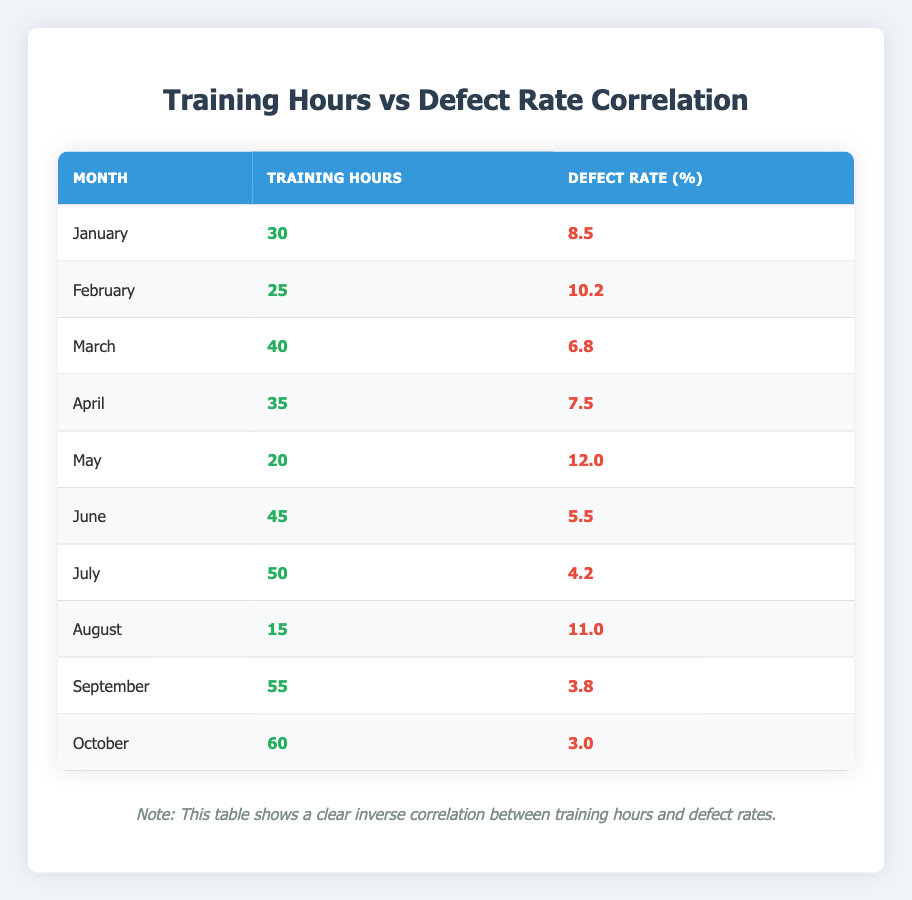What is the defect rate in June? In the table, the defect rate for June corresponds to the row where the month is June. The defect rate listed there is 5.5%.
Answer: 5.5 Which month had the highest training hours? By examining the training hours for each month in the table, September has the highest training hours at 55.
Answer: September What is the average defect rate for the months with training hours above 40? For the months that have training hours greater than 40 (March, June, July, September, and October), their defect rates are 6.8, 5.5, 4.2, 3.8, and 3.0 respectively. The sum is 6.8 + 5.5 + 4.2 + 3.8 + 3.0 = 23.3. There are 5 months, so the average is 23.3 / 5 = 4.66.
Answer: 4.66 Is it true that the defect rate decreases as training hours increase? A general trend can be inferred from the data: as training hours increase, the defect rate generally decreases. Analyzing the rows confirms that lower defect rates tend to align with higher training hours.
Answer: Yes What was the defect rate in the month with the lowest training hours? In the table, the month with the lowest training hours is August, which has 15 training hours. The defect rate for this month is listed as 11.0%.
Answer: 11.0 What is the total training hours contributed by the months with defect rates below 5%? The months with defect rates below 5% are July (50 hours), September (55 hours), and October (60 hours). Summing their training hours gives 50 + 55 + 60 = 165.
Answer: 165 How many months had a defect rate above 10%? Looking at the defect rates in the table, the months February (10.2%), May (12.0%), and August (11.0%) had defect rates higher than 10%. That totals to three months.
Answer: 3 What is the difference in defect rate between the month with the maximum training hours and the month with the minimum training hours? September has the maximum training hours of 55 with a defect rate of 3.8%, and August has the minimum training hours of 15 with a defect rate of 11.0%. The difference in defect rates is 11.0 - 3.8 = 7.2%.
Answer: 7.2 Which month showed the most significant defect rate decrease compared to the previous month? To identify the most significant decrease between consecutive months, we compare the defect rates: January to February shows a change of 8.5 - 10.2 = -1.7, February to March shows -10.2 - 6.8 = 3.4, and so on. The highest decrease is from May to June, which is 12.0 - 5.5 = 6.5.
Answer: May to June 